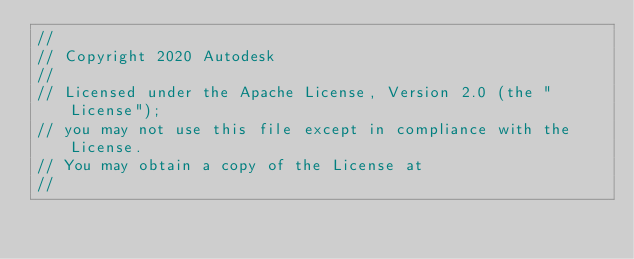Convert code to text. <code><loc_0><loc_0><loc_500><loc_500><_C_>//
// Copyright 2020 Autodesk
//
// Licensed under the Apache License, Version 2.0 (the "License");
// you may not use this file except in compliance with the License.
// You may obtain a copy of the License at
//</code> 